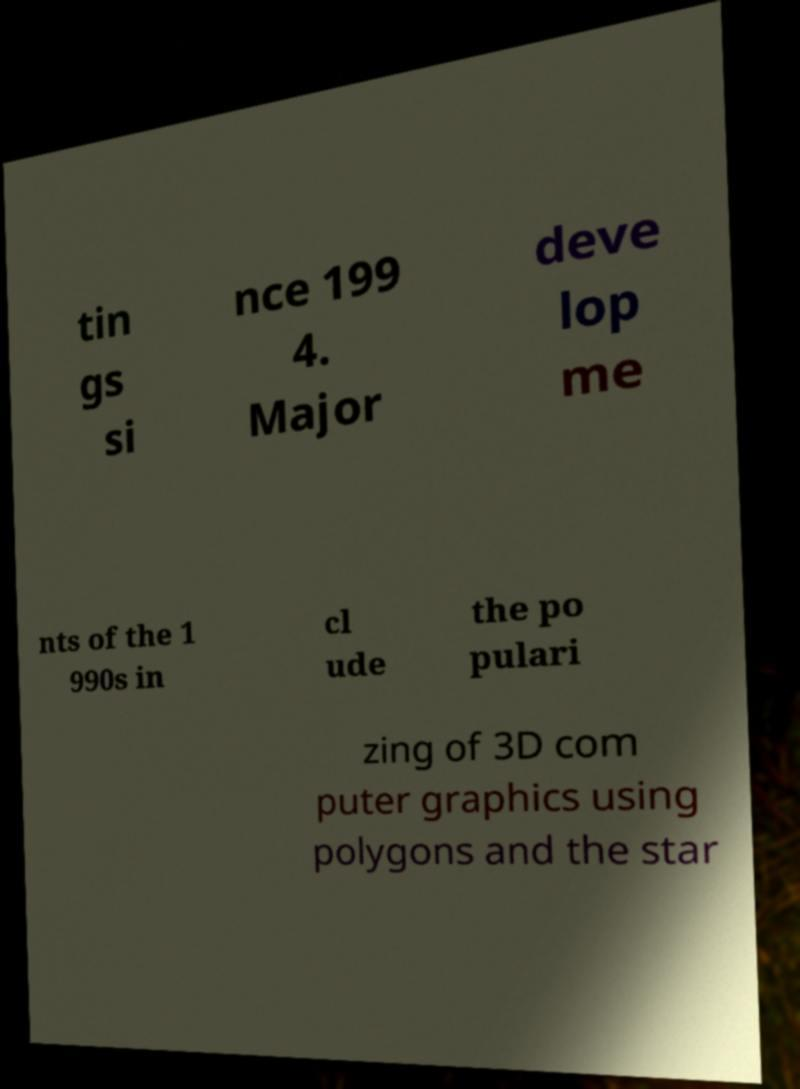Can you accurately transcribe the text from the provided image for me? tin gs si nce 199 4. Major deve lop me nts of the 1 990s in cl ude the po pulari zing of 3D com puter graphics using polygons and the star 